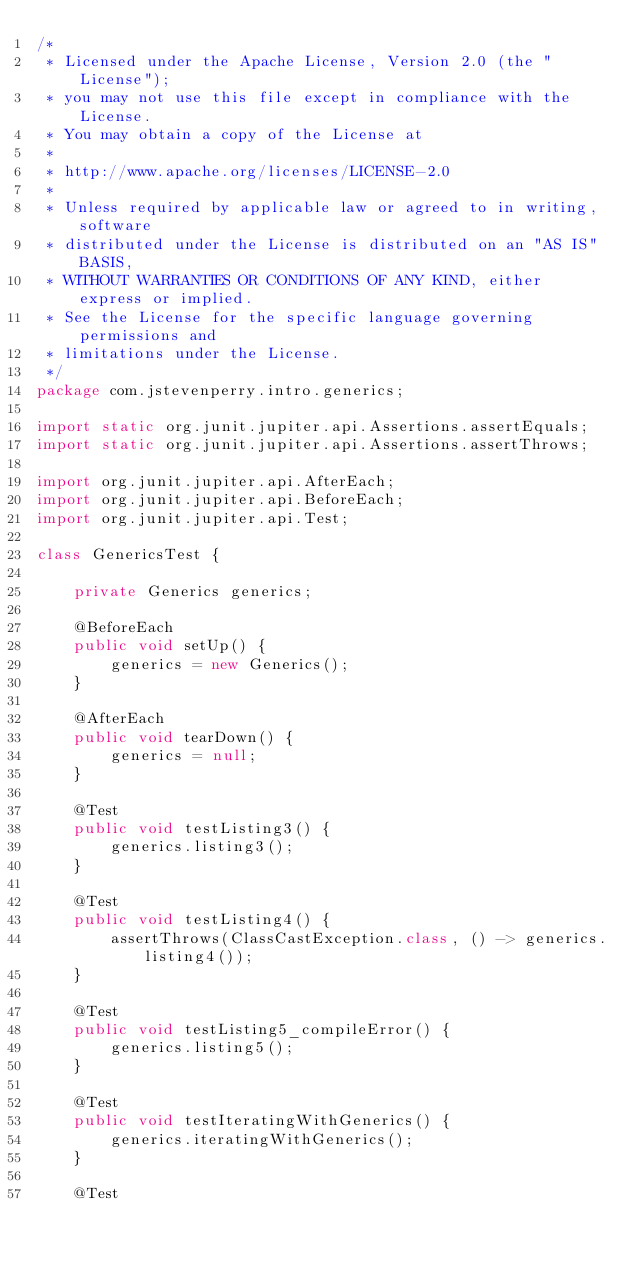<code> <loc_0><loc_0><loc_500><loc_500><_Java_>/*
 * Licensed under the Apache License, Version 2.0 (the "License");
 * you may not use this file except in compliance with the License.
 * You may obtain a copy of the License at
 *
 * http://www.apache.org/licenses/LICENSE-2.0
 *
 * Unless required by applicable law or agreed to in writing, software
 * distributed under the License is distributed on an "AS IS" BASIS,
 * WITHOUT WARRANTIES OR CONDITIONS OF ANY KIND, either express or implied.
 * See the License for the specific language governing permissions and
 * limitations under the License.
 */
package com.jstevenperry.intro.generics;

import static org.junit.jupiter.api.Assertions.assertEquals;
import static org.junit.jupiter.api.Assertions.assertThrows;

import org.junit.jupiter.api.AfterEach;
import org.junit.jupiter.api.BeforeEach;
import org.junit.jupiter.api.Test;

class GenericsTest {

    private Generics generics;

    @BeforeEach
    public void setUp() {
        generics = new Generics();
    }

    @AfterEach
    public void tearDown() {
        generics = null;
    }

    @Test
    public void testListing3() {
        generics.listing3();
    }

    @Test
    public void testListing4() {
        assertThrows(ClassCastException.class, () -> generics.listing4());
    }

    @Test
    public void testListing5_compileError() {
        generics.listing5();
    }

    @Test
    public void testIteratingWithGenerics() {
        generics.iteratingWithGenerics();
    }

    @Test</code> 